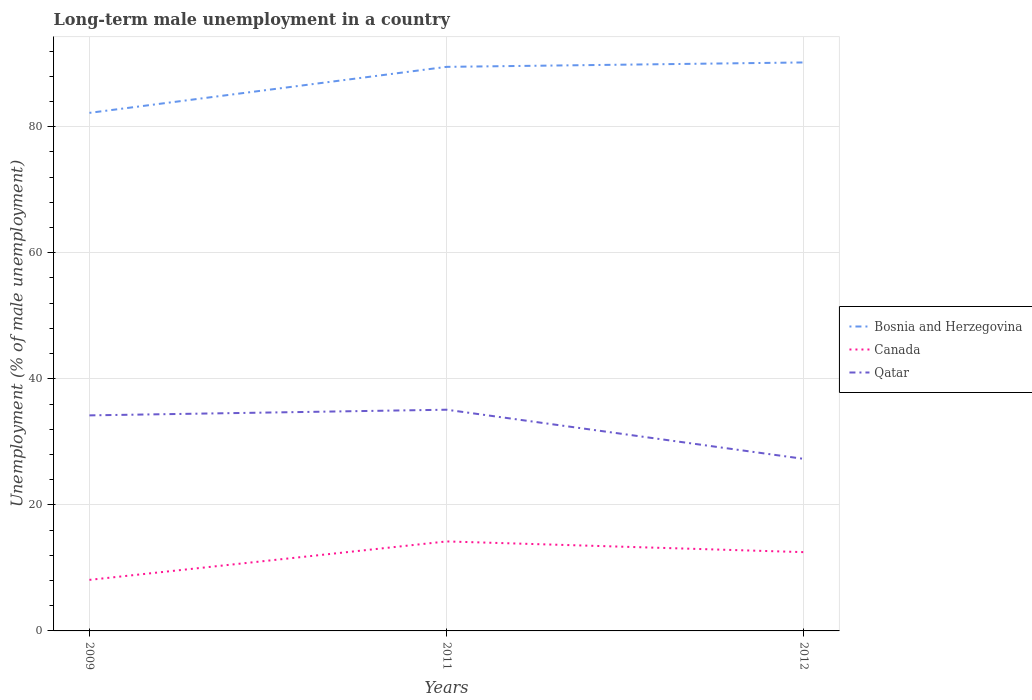Does the line corresponding to Canada intersect with the line corresponding to Bosnia and Herzegovina?
Offer a very short reply. No. Is the number of lines equal to the number of legend labels?
Make the answer very short. Yes. Across all years, what is the maximum percentage of long-term unemployed male population in Bosnia and Herzegovina?
Provide a short and direct response. 82.2. What is the total percentage of long-term unemployed male population in Canada in the graph?
Offer a very short reply. 1.7. What is the difference between the highest and the second highest percentage of long-term unemployed male population in Bosnia and Herzegovina?
Provide a succinct answer. 8. What is the difference between two consecutive major ticks on the Y-axis?
Give a very brief answer. 20. Does the graph contain grids?
Give a very brief answer. Yes. Where does the legend appear in the graph?
Your answer should be very brief. Center right. How many legend labels are there?
Your answer should be very brief. 3. What is the title of the graph?
Offer a very short reply. Long-term male unemployment in a country. What is the label or title of the X-axis?
Give a very brief answer. Years. What is the label or title of the Y-axis?
Make the answer very short. Unemployment (% of male unemployment). What is the Unemployment (% of male unemployment) of Bosnia and Herzegovina in 2009?
Make the answer very short. 82.2. What is the Unemployment (% of male unemployment) of Canada in 2009?
Your answer should be very brief. 8.1. What is the Unemployment (% of male unemployment) of Qatar in 2009?
Your response must be concise. 34.2. What is the Unemployment (% of male unemployment) of Bosnia and Herzegovina in 2011?
Ensure brevity in your answer.  89.5. What is the Unemployment (% of male unemployment) of Canada in 2011?
Provide a short and direct response. 14.2. What is the Unemployment (% of male unemployment) of Qatar in 2011?
Provide a short and direct response. 35.1. What is the Unemployment (% of male unemployment) of Bosnia and Herzegovina in 2012?
Offer a terse response. 90.2. What is the Unemployment (% of male unemployment) in Qatar in 2012?
Your answer should be compact. 27.3. Across all years, what is the maximum Unemployment (% of male unemployment) of Bosnia and Herzegovina?
Your answer should be very brief. 90.2. Across all years, what is the maximum Unemployment (% of male unemployment) in Canada?
Provide a succinct answer. 14.2. Across all years, what is the maximum Unemployment (% of male unemployment) of Qatar?
Offer a terse response. 35.1. Across all years, what is the minimum Unemployment (% of male unemployment) of Bosnia and Herzegovina?
Provide a short and direct response. 82.2. Across all years, what is the minimum Unemployment (% of male unemployment) in Canada?
Ensure brevity in your answer.  8.1. Across all years, what is the minimum Unemployment (% of male unemployment) of Qatar?
Offer a terse response. 27.3. What is the total Unemployment (% of male unemployment) of Bosnia and Herzegovina in the graph?
Make the answer very short. 261.9. What is the total Unemployment (% of male unemployment) in Canada in the graph?
Provide a short and direct response. 34.8. What is the total Unemployment (% of male unemployment) in Qatar in the graph?
Give a very brief answer. 96.6. What is the difference between the Unemployment (% of male unemployment) in Qatar in 2009 and that in 2011?
Offer a very short reply. -0.9. What is the difference between the Unemployment (% of male unemployment) in Bosnia and Herzegovina in 2009 and that in 2012?
Offer a terse response. -8. What is the difference between the Unemployment (% of male unemployment) in Canada in 2009 and that in 2012?
Your answer should be very brief. -4.4. What is the difference between the Unemployment (% of male unemployment) of Bosnia and Herzegovina in 2009 and the Unemployment (% of male unemployment) of Canada in 2011?
Make the answer very short. 68. What is the difference between the Unemployment (% of male unemployment) in Bosnia and Herzegovina in 2009 and the Unemployment (% of male unemployment) in Qatar in 2011?
Your answer should be very brief. 47.1. What is the difference between the Unemployment (% of male unemployment) in Canada in 2009 and the Unemployment (% of male unemployment) in Qatar in 2011?
Provide a succinct answer. -27. What is the difference between the Unemployment (% of male unemployment) of Bosnia and Herzegovina in 2009 and the Unemployment (% of male unemployment) of Canada in 2012?
Your answer should be very brief. 69.7. What is the difference between the Unemployment (% of male unemployment) of Bosnia and Herzegovina in 2009 and the Unemployment (% of male unemployment) of Qatar in 2012?
Keep it short and to the point. 54.9. What is the difference between the Unemployment (% of male unemployment) in Canada in 2009 and the Unemployment (% of male unemployment) in Qatar in 2012?
Your answer should be compact. -19.2. What is the difference between the Unemployment (% of male unemployment) of Bosnia and Herzegovina in 2011 and the Unemployment (% of male unemployment) of Qatar in 2012?
Provide a succinct answer. 62.2. What is the average Unemployment (% of male unemployment) in Bosnia and Herzegovina per year?
Make the answer very short. 87.3. What is the average Unemployment (% of male unemployment) of Qatar per year?
Your answer should be very brief. 32.2. In the year 2009, what is the difference between the Unemployment (% of male unemployment) in Bosnia and Herzegovina and Unemployment (% of male unemployment) in Canada?
Give a very brief answer. 74.1. In the year 2009, what is the difference between the Unemployment (% of male unemployment) in Bosnia and Herzegovina and Unemployment (% of male unemployment) in Qatar?
Your answer should be very brief. 48. In the year 2009, what is the difference between the Unemployment (% of male unemployment) of Canada and Unemployment (% of male unemployment) of Qatar?
Offer a terse response. -26.1. In the year 2011, what is the difference between the Unemployment (% of male unemployment) in Bosnia and Herzegovina and Unemployment (% of male unemployment) in Canada?
Your response must be concise. 75.3. In the year 2011, what is the difference between the Unemployment (% of male unemployment) in Bosnia and Herzegovina and Unemployment (% of male unemployment) in Qatar?
Give a very brief answer. 54.4. In the year 2011, what is the difference between the Unemployment (% of male unemployment) of Canada and Unemployment (% of male unemployment) of Qatar?
Offer a very short reply. -20.9. In the year 2012, what is the difference between the Unemployment (% of male unemployment) of Bosnia and Herzegovina and Unemployment (% of male unemployment) of Canada?
Offer a terse response. 77.7. In the year 2012, what is the difference between the Unemployment (% of male unemployment) in Bosnia and Herzegovina and Unemployment (% of male unemployment) in Qatar?
Make the answer very short. 62.9. In the year 2012, what is the difference between the Unemployment (% of male unemployment) in Canada and Unemployment (% of male unemployment) in Qatar?
Your answer should be very brief. -14.8. What is the ratio of the Unemployment (% of male unemployment) of Bosnia and Herzegovina in 2009 to that in 2011?
Provide a short and direct response. 0.92. What is the ratio of the Unemployment (% of male unemployment) of Canada in 2009 to that in 2011?
Offer a terse response. 0.57. What is the ratio of the Unemployment (% of male unemployment) of Qatar in 2009 to that in 2011?
Your answer should be compact. 0.97. What is the ratio of the Unemployment (% of male unemployment) in Bosnia and Herzegovina in 2009 to that in 2012?
Your response must be concise. 0.91. What is the ratio of the Unemployment (% of male unemployment) in Canada in 2009 to that in 2012?
Give a very brief answer. 0.65. What is the ratio of the Unemployment (% of male unemployment) of Qatar in 2009 to that in 2012?
Your response must be concise. 1.25. What is the ratio of the Unemployment (% of male unemployment) in Bosnia and Herzegovina in 2011 to that in 2012?
Give a very brief answer. 0.99. What is the ratio of the Unemployment (% of male unemployment) in Canada in 2011 to that in 2012?
Offer a very short reply. 1.14. What is the difference between the highest and the second highest Unemployment (% of male unemployment) in Canada?
Your response must be concise. 1.7. What is the difference between the highest and the second highest Unemployment (% of male unemployment) in Qatar?
Your answer should be very brief. 0.9. What is the difference between the highest and the lowest Unemployment (% of male unemployment) of Bosnia and Herzegovina?
Your answer should be compact. 8. What is the difference between the highest and the lowest Unemployment (% of male unemployment) of Canada?
Offer a terse response. 6.1. 